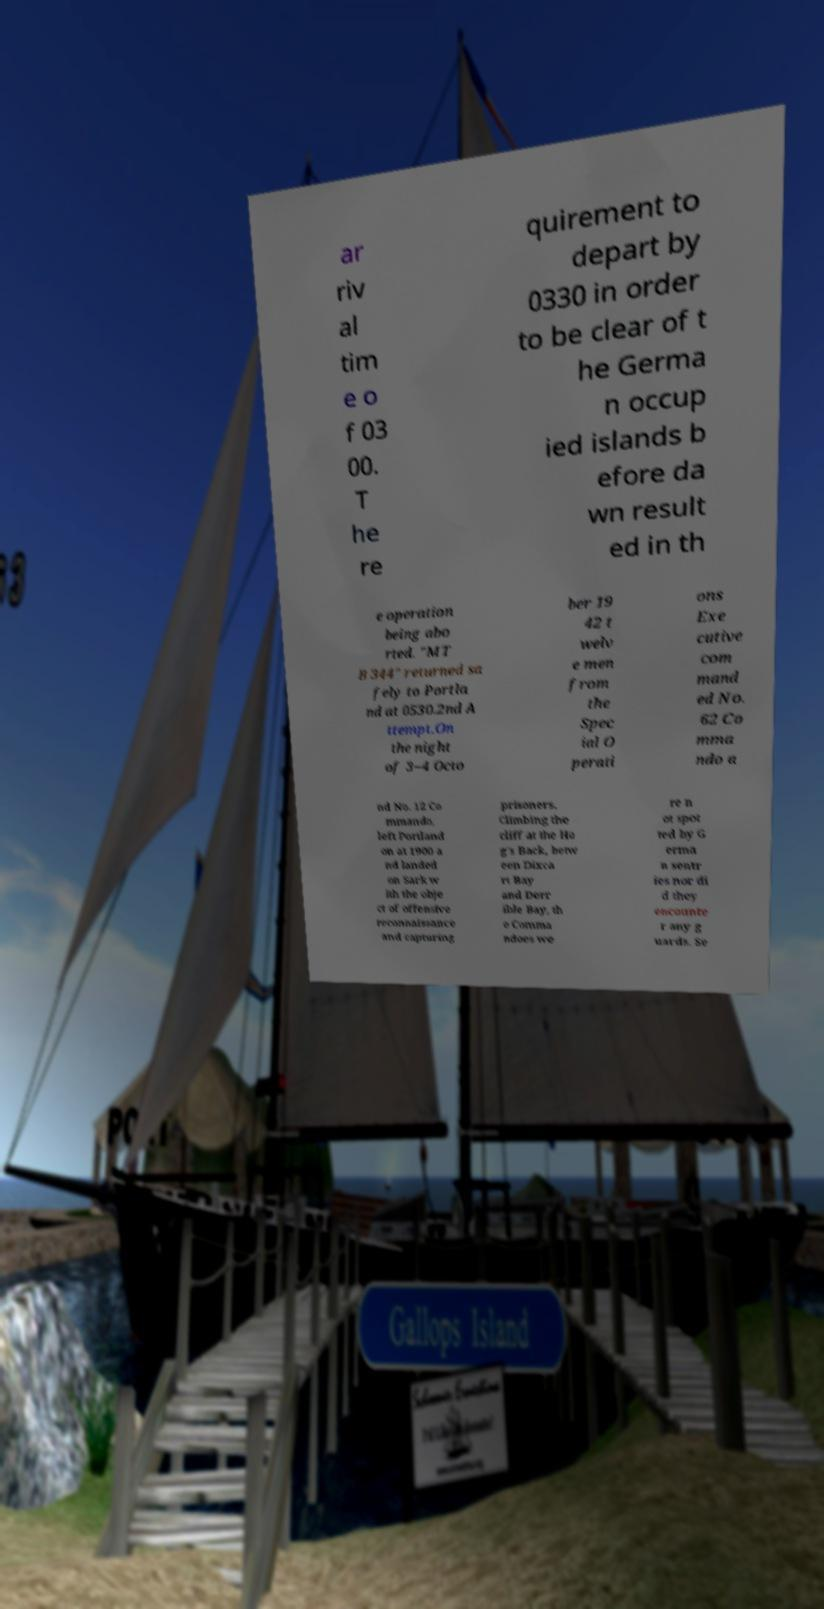Please identify and transcribe the text found in this image. ar riv al tim e o f 03 00. T he re quirement to depart by 0330 in order to be clear of t he Germa n occup ied islands b efore da wn result ed in th e operation being abo rted. "MT B 344" returned sa fely to Portla nd at 0530.2nd A ttempt.On the night of 3–4 Octo ber 19 42 t welv e men from the Spec ial O perati ons Exe cutive com mand ed No. 62 Co mma ndo a nd No. 12 Co mmando, left Portland on at 1900 a nd landed on Sark w ith the obje ct of offensive reconnaissance and capturing prisoners. Climbing the cliff at the Ho g's Back, betw een Dixca rt Bay and Derr ible Bay, th e Comma ndoes we re n ot spot ted by G erma n sentr ies nor di d they encounte r any g uards. Se 